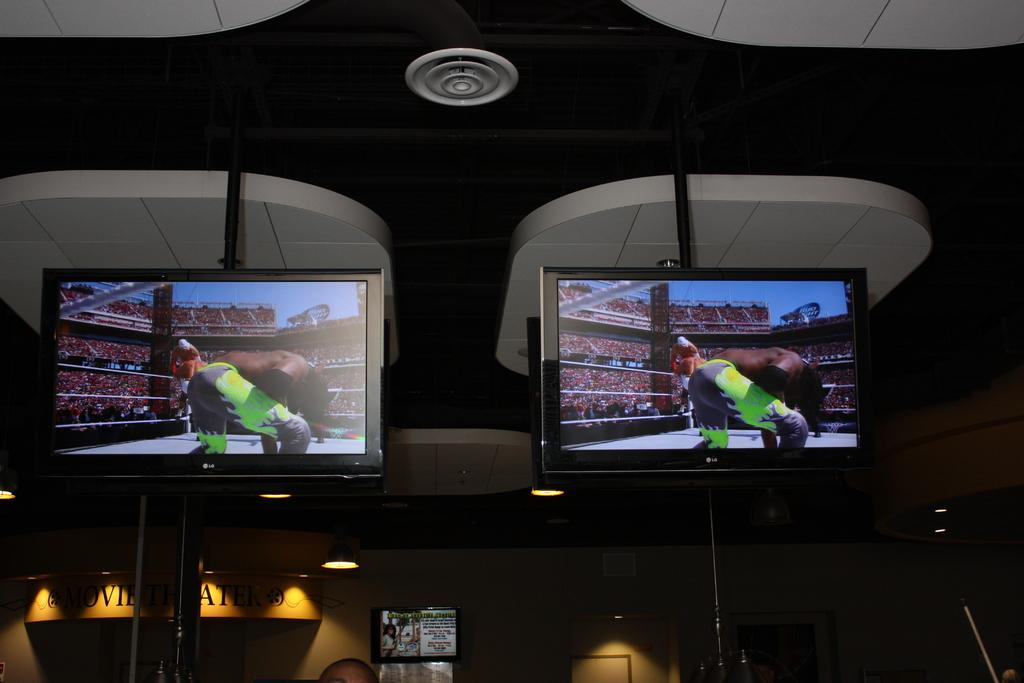What is present on the wall in the image? There is a frame on the wall. What is written or displayed on the frame? There is text associated with the frame. What is above the wall in the image? There is a ceiling in the image. How many monitors can be seen in the image? There are two monitors in the image. What is being displayed on the monitors? Pictures are displayed on the monitors. Can you see a lake in the image? There is no lake present in the image. Is there a pump visible in the image? There is no pump present in the image. 